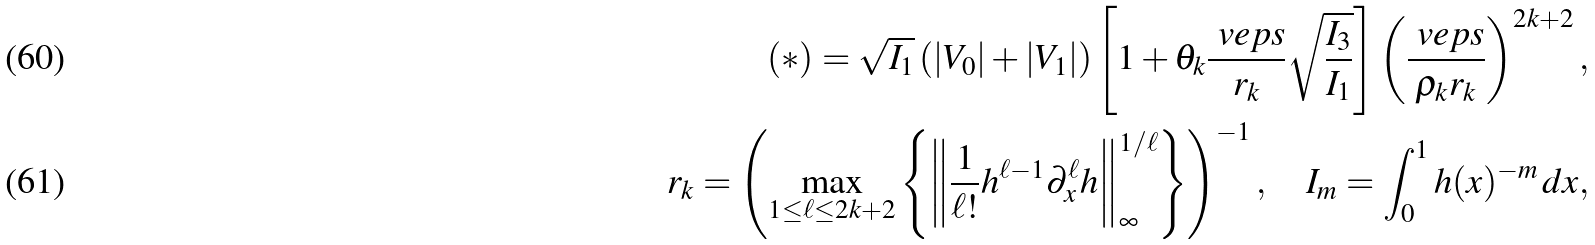<formula> <loc_0><loc_0><loc_500><loc_500>( * ) = \sqrt { I _ { 1 } } \left ( | V _ { 0 } | + | V _ { 1 } | \right ) \left [ 1 + \theta _ { k } \frac { \ v e p s } { r _ { k } } \sqrt { \frac { I _ { 3 } } { I _ { 1 } } } \right ] \left ( \frac { \ v e p s } { \rho _ { k } r _ { k } } \right ) ^ { 2 k + 2 } , \\ r _ { k } = \left ( \max _ { 1 \leq \ell \leq 2 k + 2 } \left \{ \left \| \frac { 1 } { \ell ! } h ^ { \ell - 1 } \partial _ { x } ^ { \ell } h \right \| _ { \infty } ^ { 1 / \ell } \right \} \right ) ^ { - 1 } , \quad I _ { m } = \int _ { 0 } ^ { 1 } h ( x ) ^ { - m } \, d x ,</formula> 